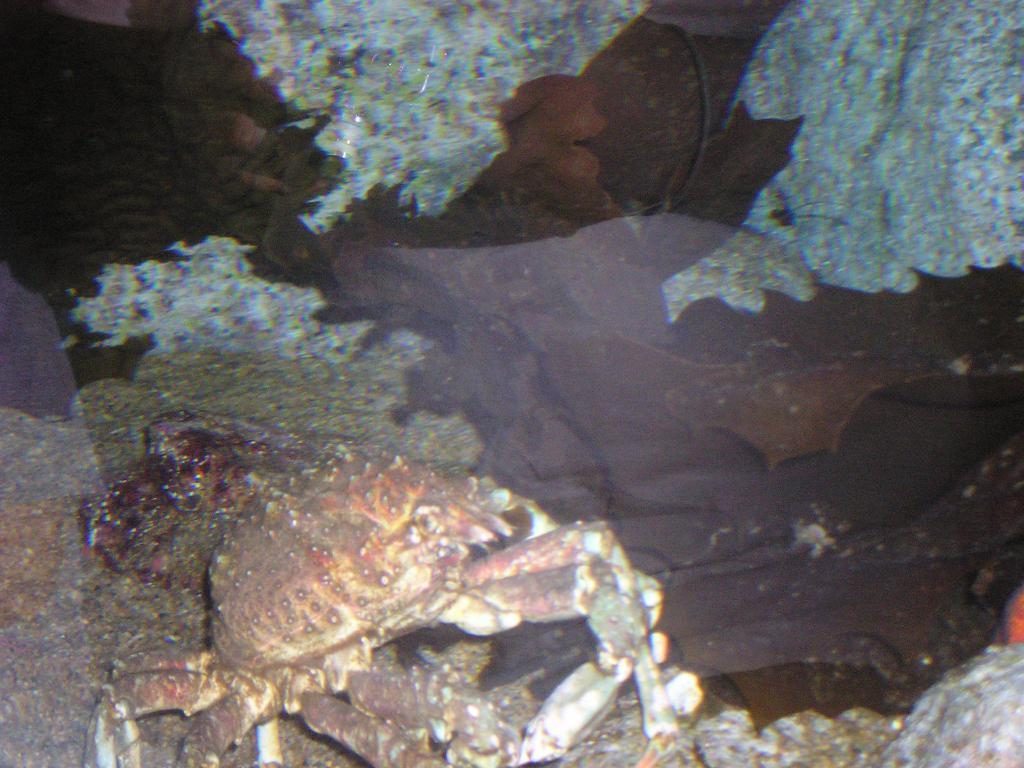What animal is present in the image? There is a crab in the image. Where is the crab located? The crab is in the water. What type of quince is being used to measure the depth of the water in the image? There is no quince present in the image, and no depth measurement is being taken. 